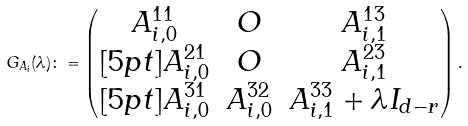<formula> <loc_0><loc_0><loc_500><loc_500>G _ { A _ { i } } ( \lambda ) \colon = \left ( \begin{matrix} A _ { i , 0 } ^ { 1 1 } & O & A _ { i , 1 } ^ { 1 3 } \\ [ 5 p t ] A _ { i , 0 } ^ { 2 1 } & O & A _ { i , 1 } ^ { 2 3 } \\ [ 5 p t ] A _ { i , 0 } ^ { 3 1 } & A _ { i , 0 } ^ { 3 2 } & A _ { i , 1 } ^ { 3 3 } + \lambda I _ { d - r } \end{matrix} \right ) .</formula> 